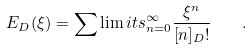Convert formula to latex. <formula><loc_0><loc_0><loc_500><loc_500>E _ { D } ( \xi ) = \sum \lim i t s _ { n = 0 } ^ { \infty } \frac { \xi ^ { n } } { [ n ] _ { D } ! } \quad .</formula> 